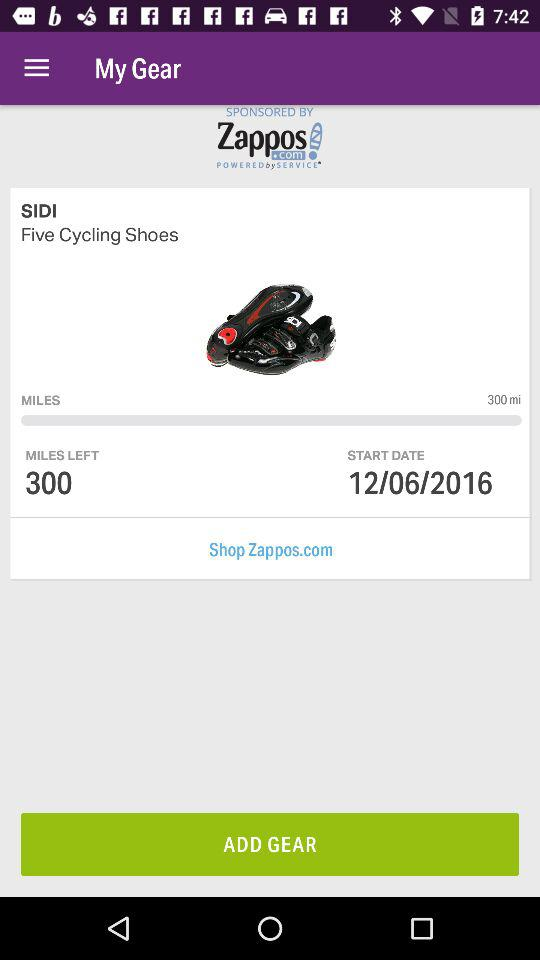How many miles do I have left to reach my goal?
Answer the question using a single word or phrase. 300 